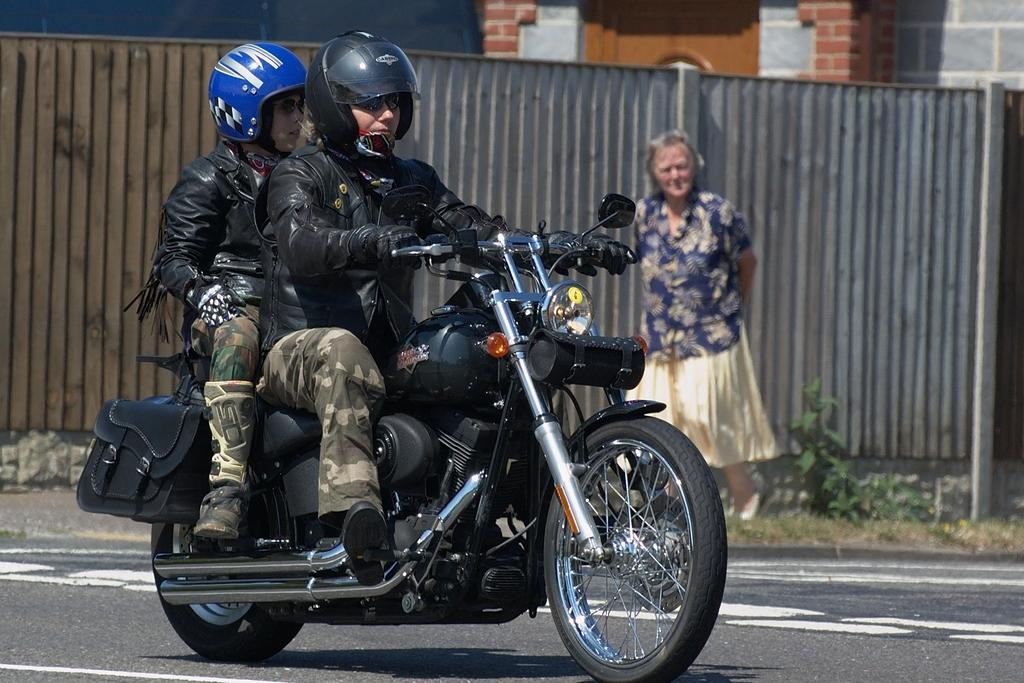What is the main feature of the image? There is a road in the image. What can be seen on the road? There is a black-colored bike on the road. How many people are on the bike? Two persons are sitting on the bike. What is visible in the background of the image? There is a wall in the background of the image, and a woman is standing there. What type of pest can be seen crawling on the bike in the image? There are no pests visible on the bike in the image. How many thumbs does the woman in the background have? The number of thumbs the woman has cannot be determined from the image. 